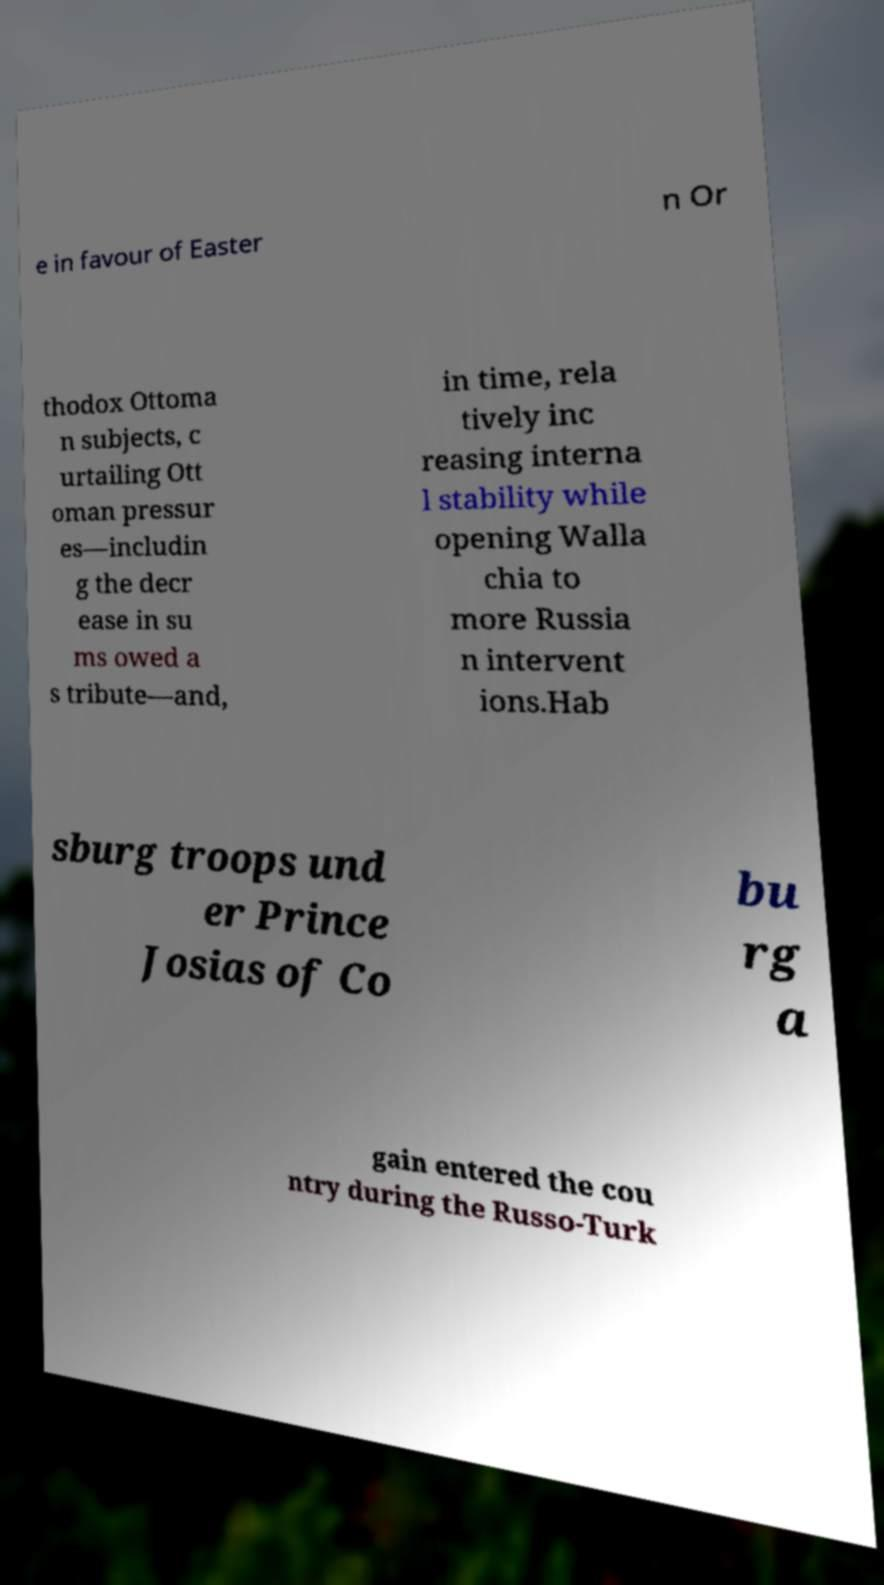What messages or text are displayed in this image? I need them in a readable, typed format. e in favour of Easter n Or thodox Ottoma n subjects, c urtailing Ott oman pressur es—includin g the decr ease in su ms owed a s tribute—and, in time, rela tively inc reasing interna l stability while opening Walla chia to more Russia n intervent ions.Hab sburg troops und er Prince Josias of Co bu rg a gain entered the cou ntry during the Russo-Turk 